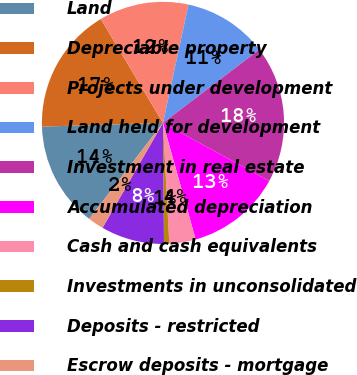Convert chart to OTSL. <chart><loc_0><loc_0><loc_500><loc_500><pie_chart><fcel>Land<fcel>Depreciable property<fcel>Projects under development<fcel>Land held for development<fcel>Investment in real estate<fcel>Accumulated depreciation<fcel>Cash and cash equivalents<fcel>Investments in unconsolidated<fcel>Deposits - restricted<fcel>Escrow deposits - mortgage<nl><fcel>14.08%<fcel>16.9%<fcel>11.97%<fcel>11.27%<fcel>18.31%<fcel>12.68%<fcel>3.52%<fcel>0.7%<fcel>8.45%<fcel>2.11%<nl></chart> 